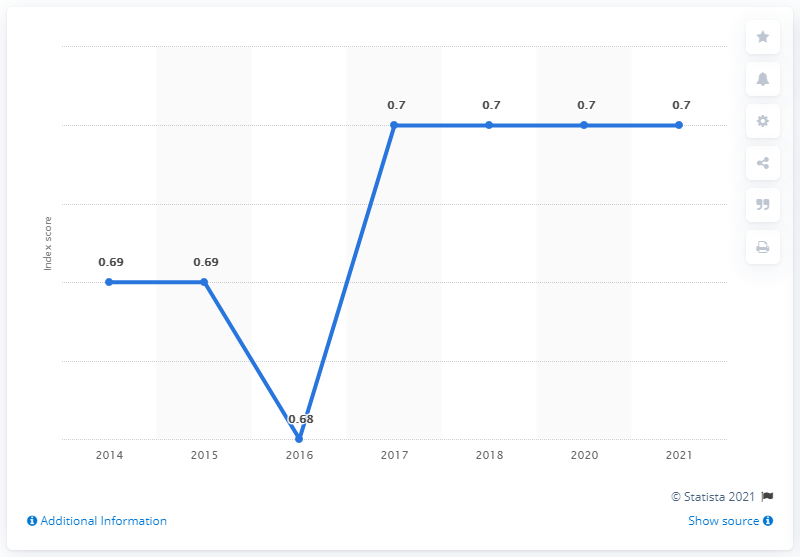Mention a couple of crucial points in this snapshot. From 2017 to 2021, the gender gap index score for the Dominican Republic was 0.7, indicating a moderate gender disparity in the country. 